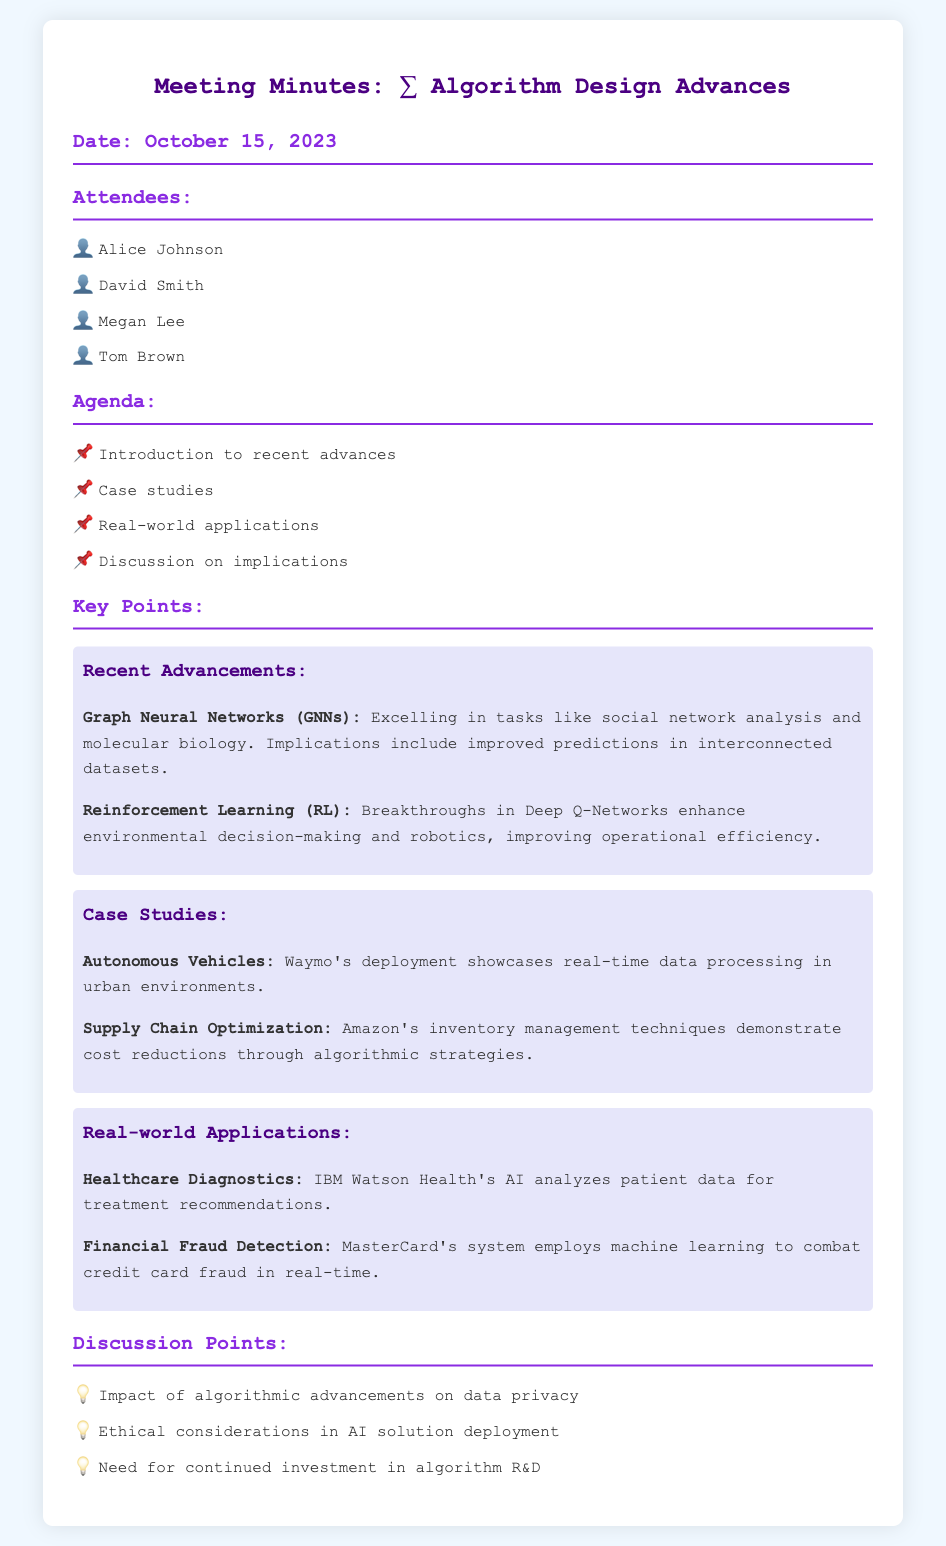What is the date of the meeting? The date of the meeting is stated at the top of the document.
Answer: October 15, 2023 Who is one of the attendees? One of the attendees is listed under the attendees section.
Answer: Alice Johnson What is a recent advancement mentioned in the meeting? The recent advancements are detailed in the key points section of the document.
Answer: Graph Neural Networks What case study involves real-time data processing? The case studies are discussed, and one of them mentions real-time data processing.
Answer: Autonomous Vehicles What is one application of algorithm design in healthcare? The real-world applications section highlights a specific application in healthcare.
Answer: Healthcare Diagnostics What is a discussion point raised regarding AI solutions? The discussion points include various topics related to algorithmic advancements.
Answer: Ethical considerations in AI solution deployment How many attendees are listed in the document? The total number of attendees can be counted from the attendees section.
Answer: Four What breakthrough is associated with Reinforcement Learning? The document specifies breakthroughs related to Reinforcement Learning in the key points section.
Answer: Deep Q-Networks 